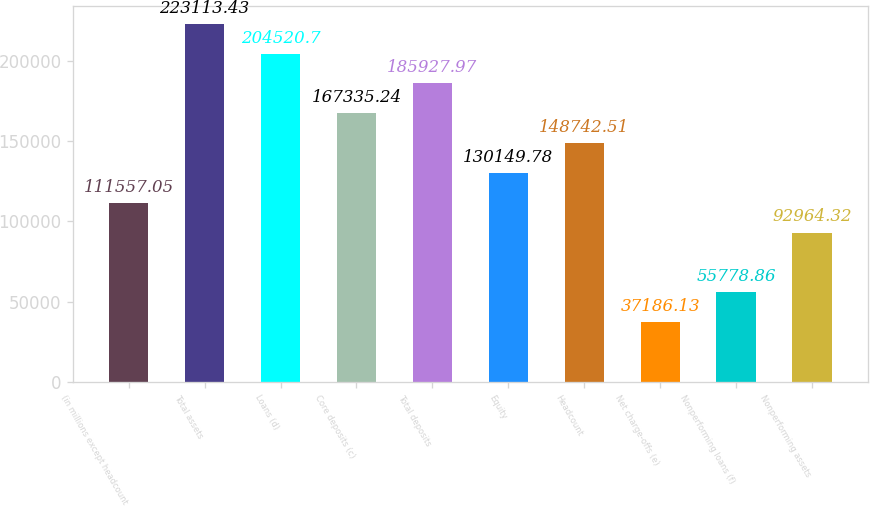<chart> <loc_0><loc_0><loc_500><loc_500><bar_chart><fcel>(in millions except headcount<fcel>Total assets<fcel>Loans (d)<fcel>Core deposits (c)<fcel>Total deposits<fcel>Equity<fcel>Headcount<fcel>Net charge-offs (e)<fcel>Nonperforming loans (f)<fcel>Nonperforming assets<nl><fcel>111557<fcel>223113<fcel>204521<fcel>167335<fcel>185928<fcel>130150<fcel>148743<fcel>37186.1<fcel>55778.9<fcel>92964.3<nl></chart> 